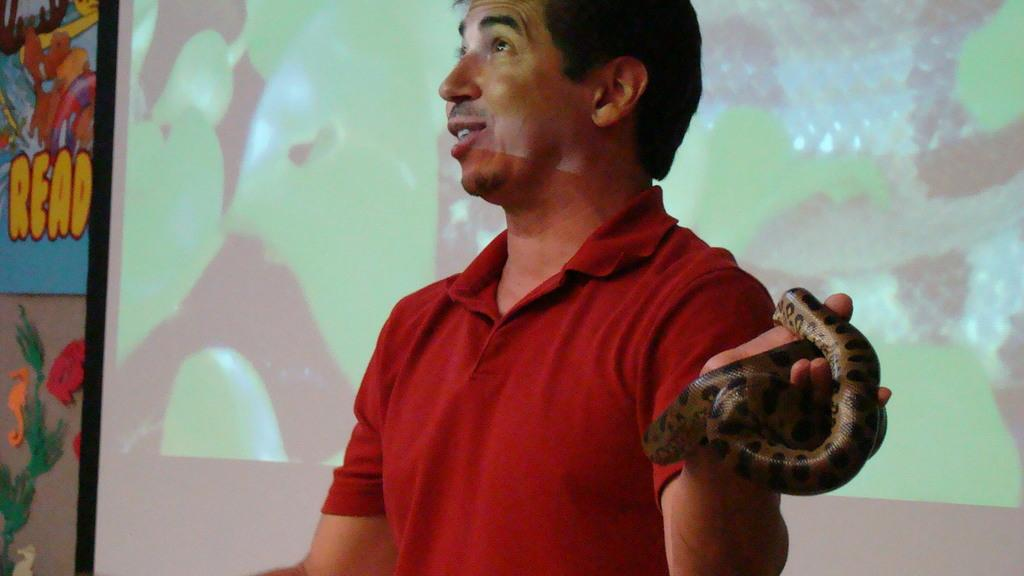What is the main subject of the image? There is a person in the image. What is the person wearing? The person is wearing a red t-shirt. What is the person doing with their mouth? The person's mouth is open. What can be seen in the background of the image? There is a colorful wall in the background of the image. Can you describe another person in the image? Yes, there is a person holding a snake in the image. Is the person in the image talking to their family about the rain? There is no mention of rain, talking, or family in the image. The image only shows a person wearing a red t-shirt with their mouth open and another person holding a snake, along with a colorful wall in the background. 